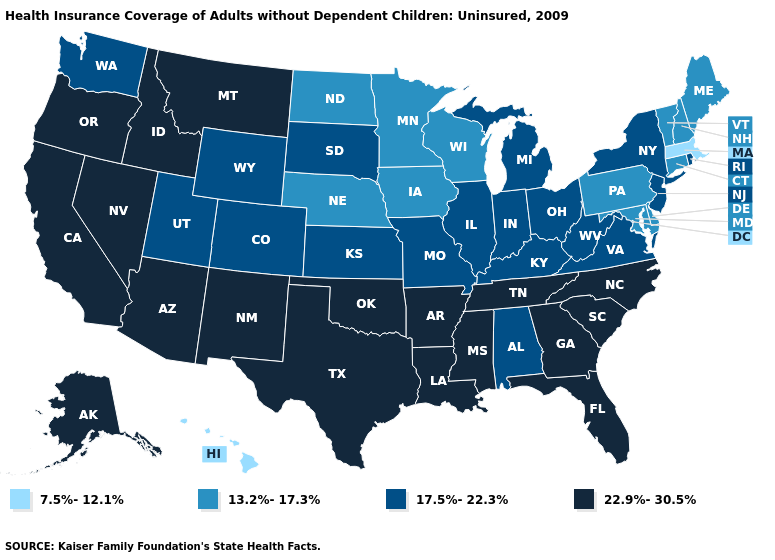What is the lowest value in states that border North Carolina?
Concise answer only. 17.5%-22.3%. Which states have the lowest value in the West?
Concise answer only. Hawaii. Does the map have missing data?
Short answer required. No. What is the highest value in the USA?
Write a very short answer. 22.9%-30.5%. What is the value of Illinois?
Concise answer only. 17.5%-22.3%. Does Kentucky have a lower value than Michigan?
Be succinct. No. Does Oklahoma have a higher value than South Carolina?
Quick response, please. No. What is the value of Pennsylvania?
Short answer required. 13.2%-17.3%. Among the states that border Texas , which have the lowest value?
Keep it brief. Arkansas, Louisiana, New Mexico, Oklahoma. What is the lowest value in the USA?
Give a very brief answer. 7.5%-12.1%. What is the lowest value in the Northeast?
Answer briefly. 7.5%-12.1%. Which states have the lowest value in the USA?
Be succinct. Hawaii, Massachusetts. What is the lowest value in the USA?
Concise answer only. 7.5%-12.1%. What is the value of New Mexico?
Be succinct. 22.9%-30.5%. Name the states that have a value in the range 7.5%-12.1%?
Be succinct. Hawaii, Massachusetts. 